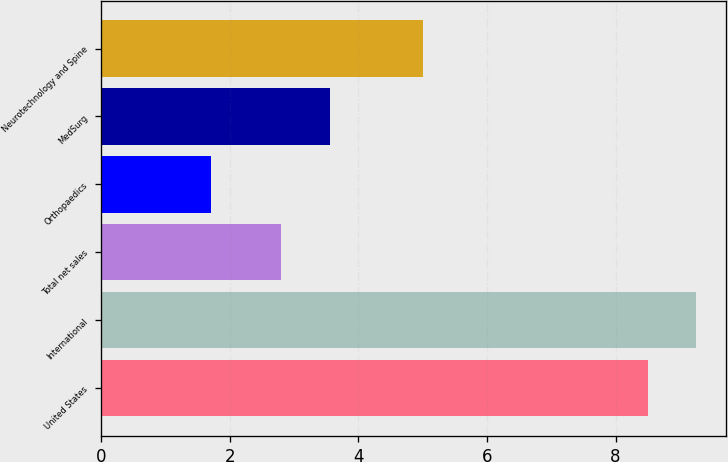Convert chart to OTSL. <chart><loc_0><loc_0><loc_500><loc_500><bar_chart><fcel>United States<fcel>International<fcel>Total net sales<fcel>Orthopaedics<fcel>MedSurg<fcel>Neurotechnology and Spine<nl><fcel>8.5<fcel>9.25<fcel>2.8<fcel>1.7<fcel>3.55<fcel>5<nl></chart> 